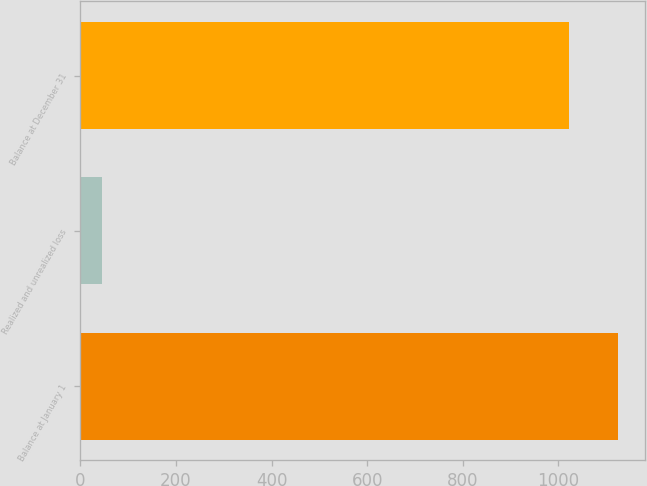Convert chart. <chart><loc_0><loc_0><loc_500><loc_500><bar_chart><fcel>Balance at January 1<fcel>Realized and unrealized loss<fcel>Balance at December 31<nl><fcel>1124.2<fcel>45<fcel>1022<nl></chart> 